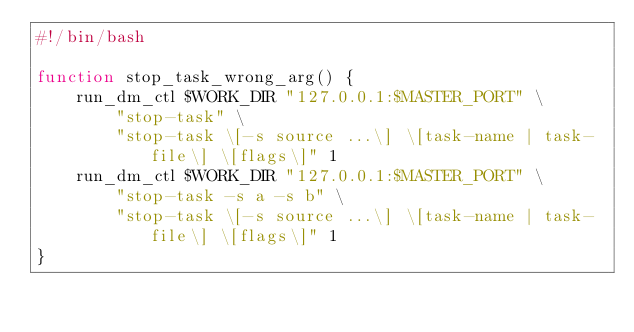Convert code to text. <code><loc_0><loc_0><loc_500><loc_500><_Bash_>#!/bin/bash

function stop_task_wrong_arg() {
	run_dm_ctl $WORK_DIR "127.0.0.1:$MASTER_PORT" \
		"stop-task" \
		"stop-task \[-s source ...\] \[task-name | task-file\] \[flags\]" 1
	run_dm_ctl $WORK_DIR "127.0.0.1:$MASTER_PORT" \
		"stop-task -s a -s b" \
		"stop-task \[-s source ...\] \[task-name | task-file\] \[flags\]" 1
}
</code> 